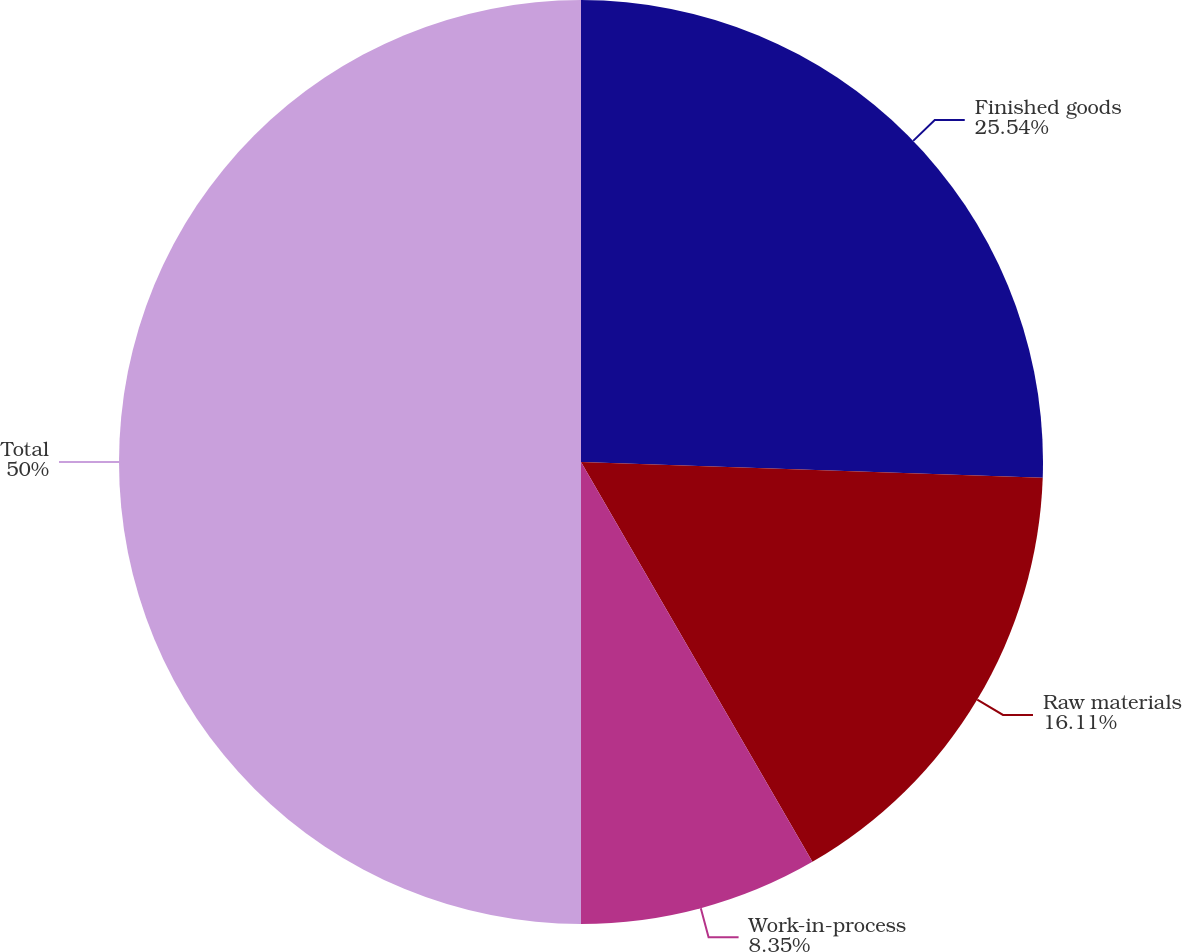Convert chart to OTSL. <chart><loc_0><loc_0><loc_500><loc_500><pie_chart><fcel>Finished goods<fcel>Raw materials<fcel>Work-in-process<fcel>Total<nl><fcel>25.54%<fcel>16.11%<fcel>8.35%<fcel>50.0%<nl></chart> 